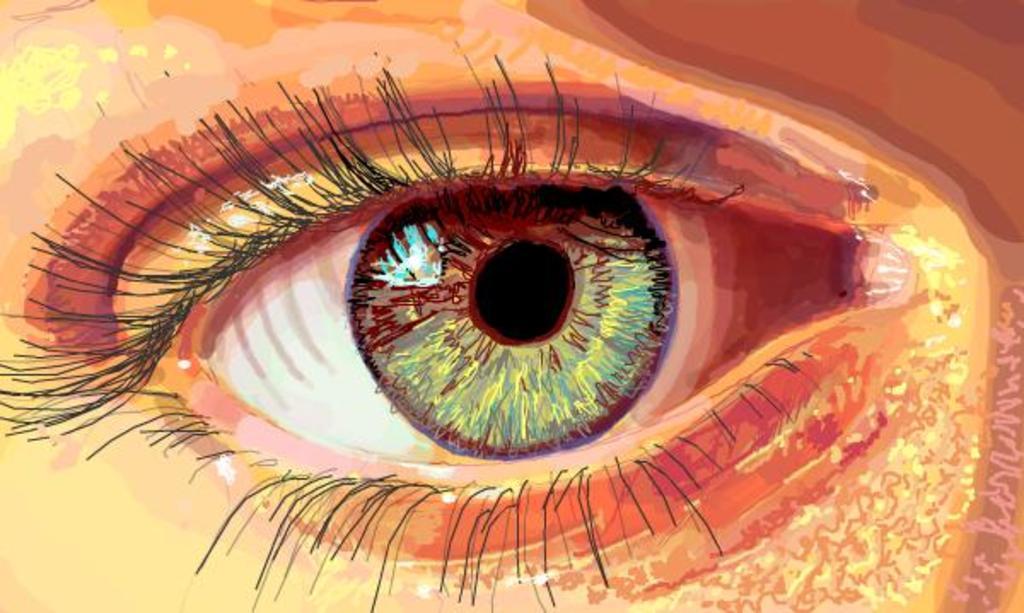Can you describe this image briefly? In this picture we can see painting of an eye. 